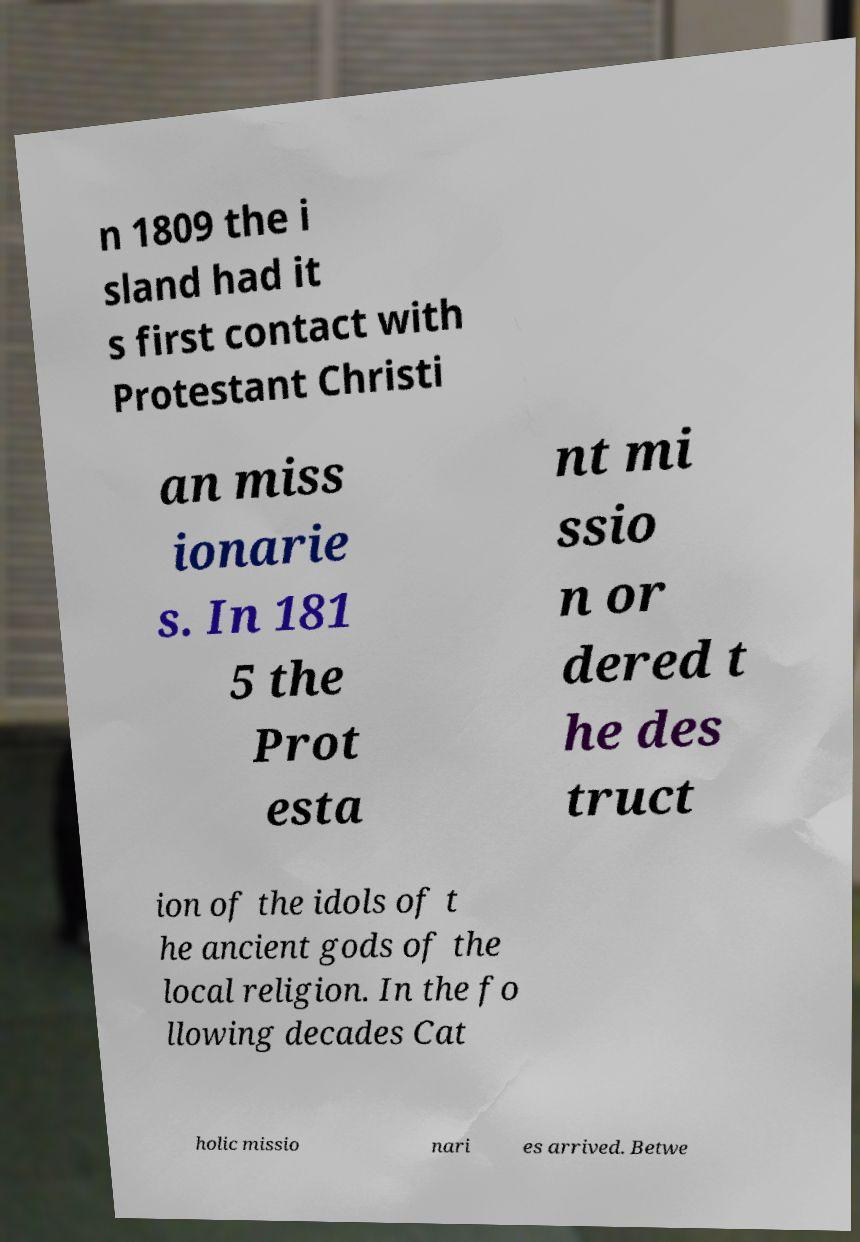Please read and relay the text visible in this image. What does it say? n 1809 the i sland had it s first contact with Protestant Christi an miss ionarie s. In 181 5 the Prot esta nt mi ssio n or dered t he des truct ion of the idols of t he ancient gods of the local religion. In the fo llowing decades Cat holic missio nari es arrived. Betwe 